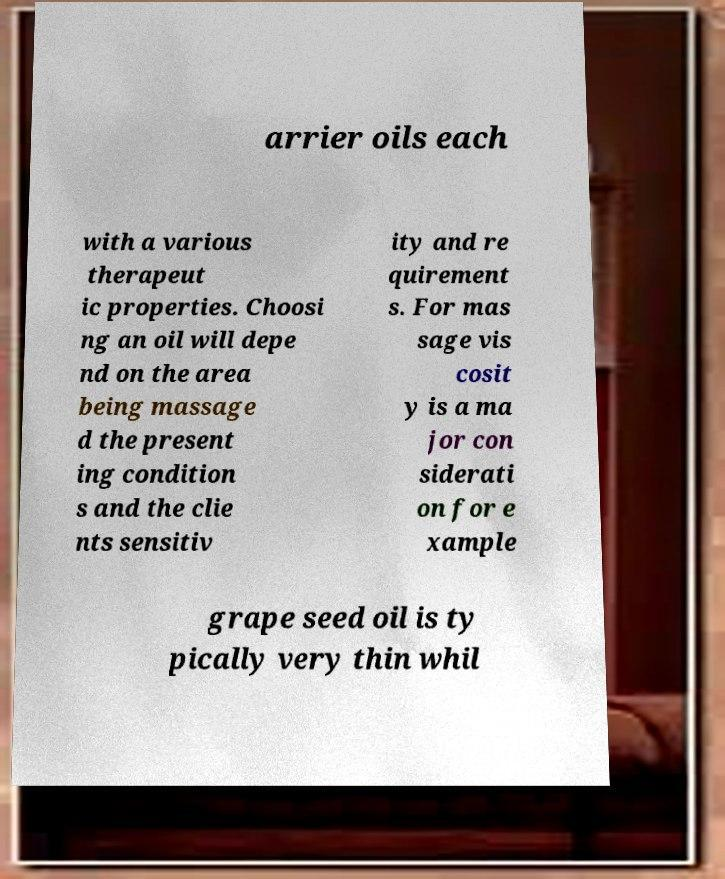There's text embedded in this image that I need extracted. Can you transcribe it verbatim? arrier oils each with a various therapeut ic properties. Choosi ng an oil will depe nd on the area being massage d the present ing condition s and the clie nts sensitiv ity and re quirement s. For mas sage vis cosit y is a ma jor con siderati on for e xample grape seed oil is ty pically very thin whil 